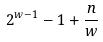Convert formula to latex. <formula><loc_0><loc_0><loc_500><loc_500>2 ^ { w - 1 } - 1 + \frac { n } { w }</formula> 